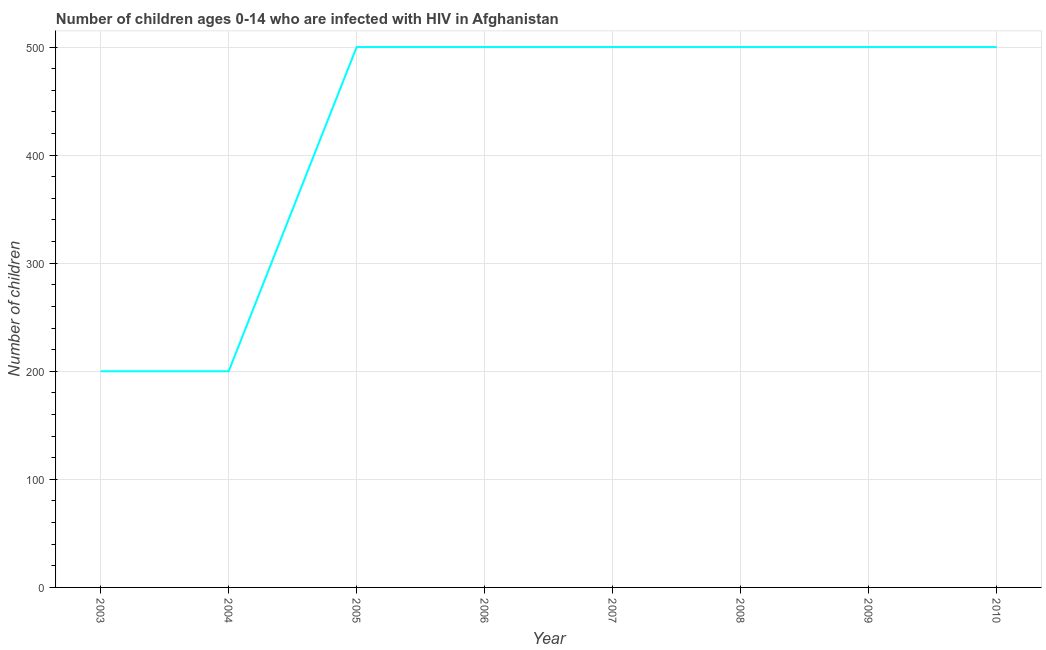What is the number of children living with hiv in 2005?
Provide a succinct answer. 500. Across all years, what is the maximum number of children living with hiv?
Your response must be concise. 500. Across all years, what is the minimum number of children living with hiv?
Give a very brief answer. 200. In which year was the number of children living with hiv maximum?
Your answer should be very brief. 2005. In which year was the number of children living with hiv minimum?
Keep it short and to the point. 2003. What is the sum of the number of children living with hiv?
Provide a short and direct response. 3400. What is the difference between the number of children living with hiv in 2009 and 2010?
Provide a succinct answer. 0. What is the average number of children living with hiv per year?
Provide a succinct answer. 425. Is the number of children living with hiv in 2006 less than that in 2008?
Offer a very short reply. No. Is the difference between the number of children living with hiv in 2003 and 2009 greater than the difference between any two years?
Provide a short and direct response. Yes. What is the difference between the highest and the second highest number of children living with hiv?
Your answer should be compact. 0. Is the sum of the number of children living with hiv in 2004 and 2010 greater than the maximum number of children living with hiv across all years?
Your answer should be compact. Yes. What is the difference between the highest and the lowest number of children living with hiv?
Provide a succinct answer. 300. Does the graph contain grids?
Keep it short and to the point. Yes. What is the title of the graph?
Provide a succinct answer. Number of children ages 0-14 who are infected with HIV in Afghanistan. What is the label or title of the X-axis?
Provide a succinct answer. Year. What is the label or title of the Y-axis?
Your answer should be very brief. Number of children. What is the Number of children in 2004?
Your response must be concise. 200. What is the Number of children in 2005?
Your response must be concise. 500. What is the Number of children of 2007?
Offer a terse response. 500. What is the Number of children of 2009?
Keep it short and to the point. 500. What is the difference between the Number of children in 2003 and 2005?
Make the answer very short. -300. What is the difference between the Number of children in 2003 and 2006?
Make the answer very short. -300. What is the difference between the Number of children in 2003 and 2007?
Keep it short and to the point. -300. What is the difference between the Number of children in 2003 and 2008?
Keep it short and to the point. -300. What is the difference between the Number of children in 2003 and 2009?
Ensure brevity in your answer.  -300. What is the difference between the Number of children in 2003 and 2010?
Ensure brevity in your answer.  -300. What is the difference between the Number of children in 2004 and 2005?
Make the answer very short. -300. What is the difference between the Number of children in 2004 and 2006?
Your response must be concise. -300. What is the difference between the Number of children in 2004 and 2007?
Offer a very short reply. -300. What is the difference between the Number of children in 2004 and 2008?
Give a very brief answer. -300. What is the difference between the Number of children in 2004 and 2009?
Make the answer very short. -300. What is the difference between the Number of children in 2004 and 2010?
Your answer should be compact. -300. What is the difference between the Number of children in 2005 and 2006?
Offer a terse response. 0. What is the difference between the Number of children in 2005 and 2009?
Your response must be concise. 0. What is the difference between the Number of children in 2006 and 2007?
Provide a short and direct response. 0. What is the difference between the Number of children in 2006 and 2009?
Provide a succinct answer. 0. What is the difference between the Number of children in 2006 and 2010?
Offer a very short reply. 0. What is the difference between the Number of children in 2007 and 2008?
Ensure brevity in your answer.  0. What is the difference between the Number of children in 2007 and 2009?
Keep it short and to the point. 0. What is the difference between the Number of children in 2007 and 2010?
Your answer should be compact. 0. What is the difference between the Number of children in 2008 and 2009?
Your answer should be very brief. 0. What is the difference between the Number of children in 2008 and 2010?
Offer a very short reply. 0. What is the ratio of the Number of children in 2003 to that in 2004?
Provide a succinct answer. 1. What is the ratio of the Number of children in 2003 to that in 2006?
Keep it short and to the point. 0.4. What is the ratio of the Number of children in 2003 to that in 2007?
Offer a very short reply. 0.4. What is the ratio of the Number of children in 2003 to that in 2009?
Your response must be concise. 0.4. What is the ratio of the Number of children in 2003 to that in 2010?
Keep it short and to the point. 0.4. What is the ratio of the Number of children in 2004 to that in 2005?
Offer a terse response. 0.4. What is the ratio of the Number of children in 2004 to that in 2006?
Offer a very short reply. 0.4. What is the ratio of the Number of children in 2004 to that in 2007?
Your answer should be very brief. 0.4. What is the ratio of the Number of children in 2004 to that in 2008?
Your answer should be compact. 0.4. What is the ratio of the Number of children in 2004 to that in 2009?
Ensure brevity in your answer.  0.4. What is the ratio of the Number of children in 2005 to that in 2006?
Your response must be concise. 1. What is the ratio of the Number of children in 2005 to that in 2007?
Your answer should be compact. 1. What is the ratio of the Number of children in 2005 to that in 2008?
Make the answer very short. 1. What is the ratio of the Number of children in 2005 to that in 2009?
Make the answer very short. 1. What is the ratio of the Number of children in 2006 to that in 2008?
Offer a terse response. 1. What is the ratio of the Number of children in 2006 to that in 2009?
Your response must be concise. 1. What is the ratio of the Number of children in 2006 to that in 2010?
Your answer should be compact. 1. What is the ratio of the Number of children in 2007 to that in 2008?
Offer a terse response. 1. What is the ratio of the Number of children in 2008 to that in 2009?
Your answer should be compact. 1. What is the ratio of the Number of children in 2008 to that in 2010?
Your answer should be very brief. 1. What is the ratio of the Number of children in 2009 to that in 2010?
Make the answer very short. 1. 